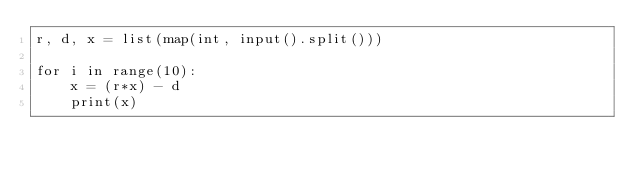Convert code to text. <code><loc_0><loc_0><loc_500><loc_500><_Python_>r, d, x = list(map(int, input().split()))

for i in range(10):
    x = (r*x) - d
    print(x)

</code> 